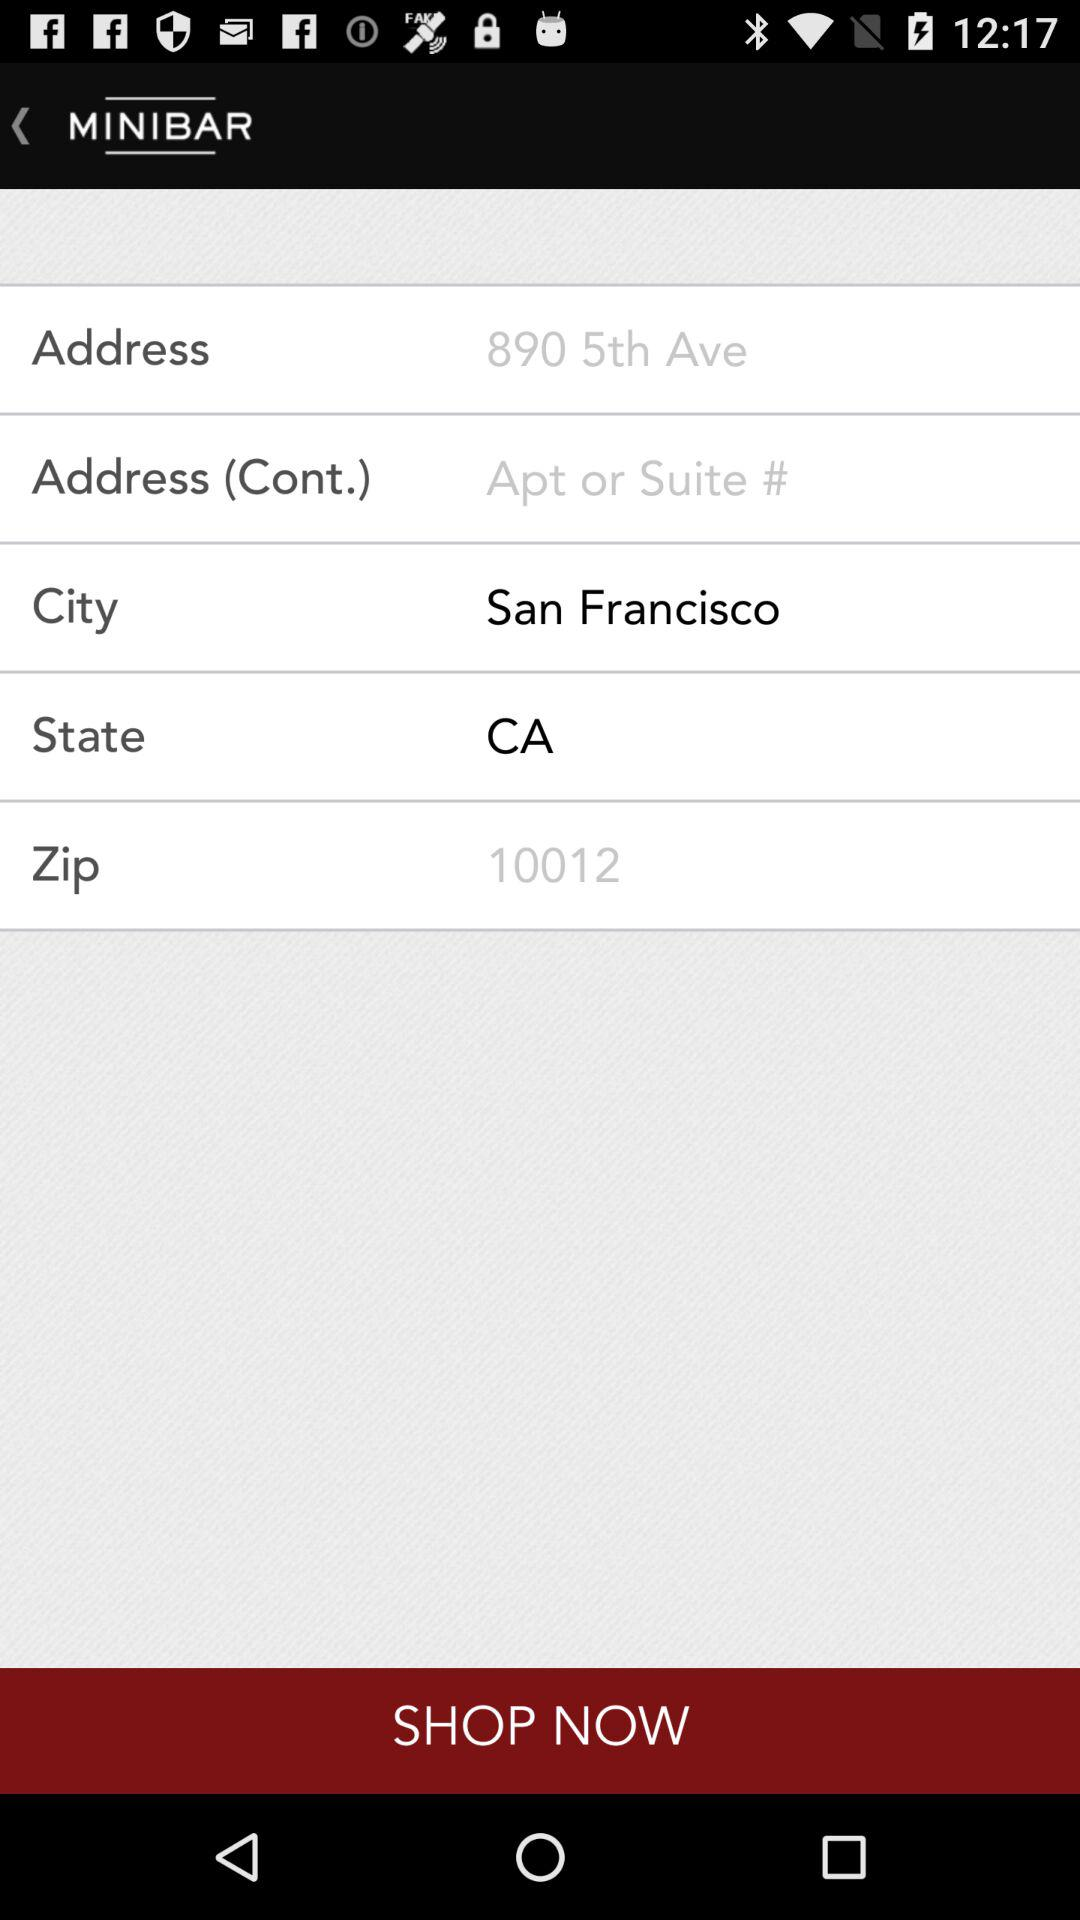What is the selected city? The selected city is San Francisco. 